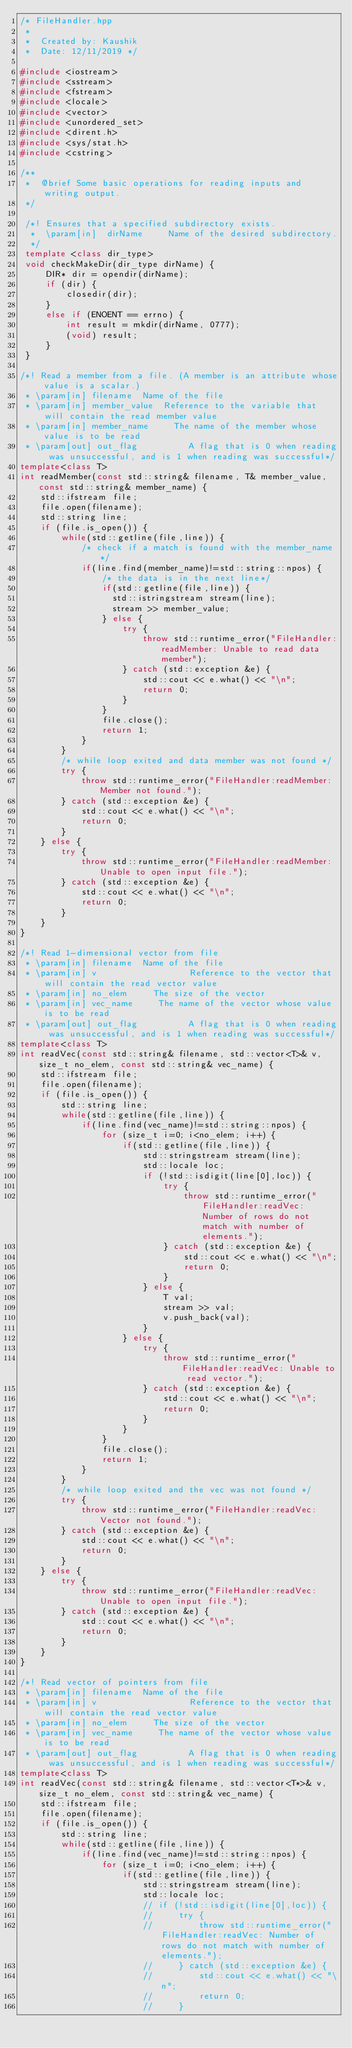<code> <loc_0><loc_0><loc_500><loc_500><_C++_>/* FileHandler.hpp
 *
 *  Created by: Kaushik
 *  Date: 12/11/2019 */

#include <iostream>
#include <sstream>
#include <fstream>
#include <locale>
#include <vector>
#include <unordered_set>
#include <dirent.h>
#include <sys/stat.h>
#include <cstring>

/**
 *  @brief Some basic operations for reading inputs and writing output.
 */

 /*! Ensures that a specified subdirectory exists.
  *  \param[in]  dirName     Name of the desired subdirectory.
  */
 template <class dir_type>
 void checkMakeDir(dir_type dirName) {
     DIR* dir = opendir(dirName);
     if (dir) {
         closedir(dir);
     }
     else if (ENOENT == errno) {
         int result = mkdir(dirName, 0777);
         (void) result;
     }
 }

/*! Read a member from a file. (A member is an attribute whose value is a scalar.)
 * \param[in] filename  Name of the file
 * \param[in] member_value  Reference to the variable that will contain the read member value
 * \param[in] member_name     The name of the member whose value is to be read
 * \param[out] out_flag          A flag that is 0 when reading was unsuccessful, and is 1 when reading was successful*/
template<class T>
int readMember(const std::string& filename, T& member_value, const std::string& member_name) {
    std::ifstream file;
    file.open(filename);
    std::string line;
    if (file.is_open()) {
        while(std::getline(file,line)) {
            /* check if a match is found with the member_name */
            if(line.find(member_name)!=std::string::npos) {
                /* the data is in the next line*/
                if(std::getline(file,line)) {
                  std::istringstream stream(line);
                  stream >> member_value;
                } else {
                    try {
                        throw std::runtime_error("FileHandler:readMember: Unable to read data member");
                    } catch (std::exception &e) {
                        std::cout << e.what() << "\n";
                        return 0;
                    }
                }
                file.close();
                return 1;
            }
        }
        /* while loop exited and data member was not found */
        try {
            throw std::runtime_error("FileHandler:readMember: Member not found.");
        } catch (std::exception &e) {
            std::cout << e.what() << "\n";
            return 0;
        }
    } else {
        try {
            throw std::runtime_error("FileHandler:readMember: Unable to open input file.");
        } catch (std::exception &e) {
            std::cout << e.what() << "\n";
            return 0;
        }
    }
}

/*! Read 1-dimensional vector from file
 * \param[in] filename  Name of the file
 * \param[in] v                  Reference to the vector that will contain the read vector value
 * \param[in] no_elem     The size of the vector
 * \param[in] vec_name     The name of the vector whose value is to be read
 * \param[out] out_flag          A flag that is 0 when reading was unsuccessful, and is 1 when reading was successful*/
template<class T>
int readVec(const std::string& filename, std::vector<T>& v, size_t no_elem, const std::string& vec_name) {
    std::ifstream file;
    file.open(filename);
    if (file.is_open()) {
        std::string line;
        while(std::getline(file,line)) {
            if(line.find(vec_name)!=std::string::npos) {
                for (size_t i=0; i<no_elem; i++) {
                    if(std::getline(file,line)) {
                        std::stringstream stream(line);
                        std::locale loc;
                        if (!std::isdigit(line[0],loc)) {
                            try {
                                throw std::runtime_error("FileHandler:readVec: Number of rows do not match with number of elements.");
                            } catch (std::exception &e) {
                                std::cout << e.what() << "\n";
                                return 0;
                            }
                        } else {
                            T val;
                            stream >> val;
                            v.push_back(val);
                        }
                    } else {
                        try {
                            throw std::runtime_error("FileHandler:readVec: Unable to read vector.");
                        } catch (std::exception &e) {
                            std::cout << e.what() << "\n";
                            return 0;
                        }
                    }
                }
                file.close();
                return 1;
            }
        }
        /* while loop exited and the vec was not found */
        try {
            throw std::runtime_error("FileHandler:readVec: Vector not found.");
        } catch (std::exception &e) {
            std::cout << e.what() << "\n";
            return 0;
        }
    } else {
        try {
            throw std::runtime_error("FileHandler:readVec: Unable to open input file.");
        } catch (std::exception &e) {
            std::cout << e.what() << "\n";
            return 0;
        }
    }
}

/*! Read vector of pointers from file
 * \param[in] filename  Name of the file
 * \param[in] v                  Reference to the vector that will contain the read vector value
 * \param[in] no_elem     The size of the vector
 * \param[in] vec_name     The name of the vector whose value is to be read
 * \param[out] out_flag          A flag that is 0 when reading was unsuccessful, and is 1 when reading was successful*/
template<class T>
int readVec(const std::string& filename, std::vector<T*>& v, size_t no_elem, const std::string& vec_name) {
    std::ifstream file;
    file.open(filename);
    if (file.is_open()) {
        std::string line;
        while(std::getline(file,line)) {
            if(line.find(vec_name)!=std::string::npos) {
                for (size_t i=0; i<no_elem; i++) {
                    if(std::getline(file,line)) {
                        std::stringstream stream(line);
                        std::locale loc;
                        // if (!std::isdigit(line[0],loc)) {
                        //     try {
                        //         throw std::runtime_error("FileHandler:readVec: Number of rows do not match with number of elements.");
                        //     } catch (std::exception &e) {
                        //         std::cout << e.what() << "\n";
                        //         return 0;
                        //     }</code> 